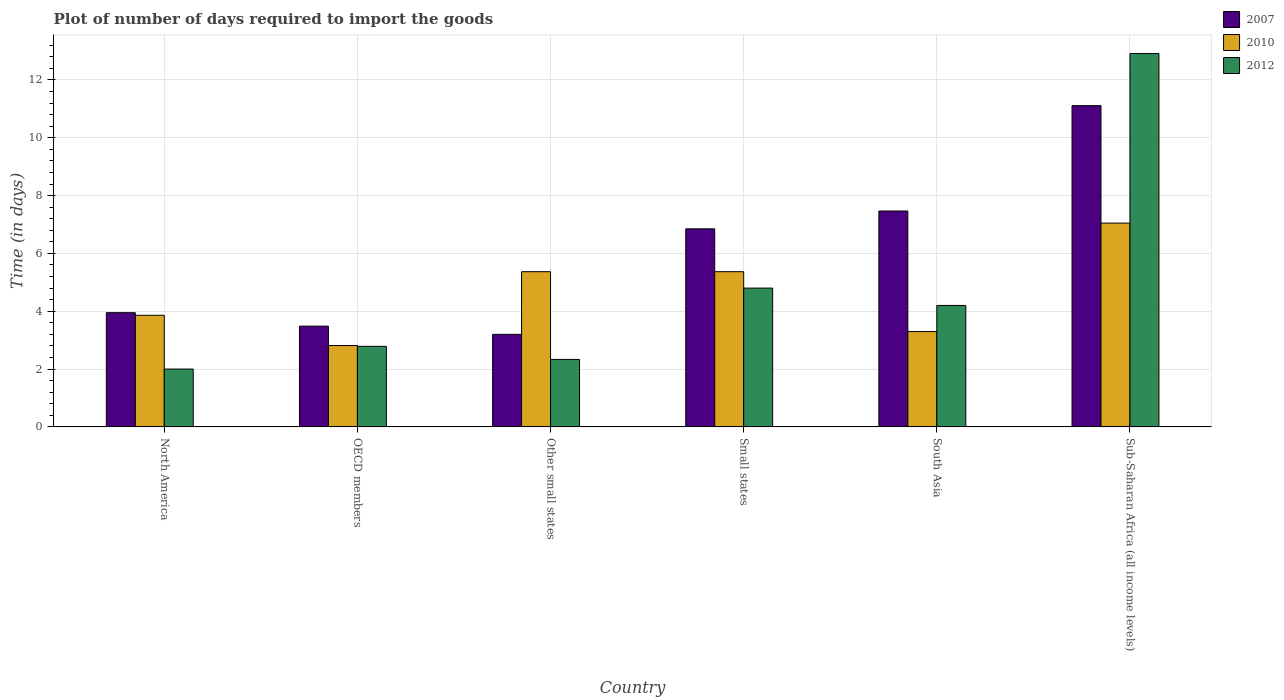How many different coloured bars are there?
Give a very brief answer. 3. How many bars are there on the 1st tick from the right?
Provide a short and direct response. 3. What is the time required to import goods in 2010 in OECD members?
Offer a very short reply. 2.81. Across all countries, what is the maximum time required to import goods in 2010?
Provide a short and direct response. 7.05. In which country was the time required to import goods in 2007 maximum?
Your response must be concise. Sub-Saharan Africa (all income levels). What is the total time required to import goods in 2012 in the graph?
Provide a short and direct response. 29.03. What is the difference between the time required to import goods in 2010 in North America and that in South Asia?
Ensure brevity in your answer.  0.56. What is the difference between the time required to import goods in 2007 in OECD members and the time required to import goods in 2012 in North America?
Provide a succinct answer. 1.48. What is the average time required to import goods in 2012 per country?
Offer a very short reply. 4.84. What is the difference between the time required to import goods of/in 2010 and time required to import goods of/in 2007 in OECD members?
Provide a succinct answer. -0.67. What is the ratio of the time required to import goods in 2007 in Other small states to that in South Asia?
Provide a succinct answer. 0.43. What is the difference between the highest and the second highest time required to import goods in 2010?
Offer a terse response. -1.68. What is the difference between the highest and the lowest time required to import goods in 2007?
Your answer should be compact. 7.91. In how many countries, is the time required to import goods in 2010 greater than the average time required to import goods in 2010 taken over all countries?
Make the answer very short. 3. Is the sum of the time required to import goods in 2010 in North America and Other small states greater than the maximum time required to import goods in 2012 across all countries?
Provide a succinct answer. No. What does the 3rd bar from the left in Sub-Saharan Africa (all income levels) represents?
Make the answer very short. 2012. Is it the case that in every country, the sum of the time required to import goods in 2010 and time required to import goods in 2007 is greater than the time required to import goods in 2012?
Offer a terse response. Yes. How many bars are there?
Make the answer very short. 18. Are all the bars in the graph horizontal?
Ensure brevity in your answer.  No. How many countries are there in the graph?
Make the answer very short. 6. What is the difference between two consecutive major ticks on the Y-axis?
Keep it short and to the point. 2. Are the values on the major ticks of Y-axis written in scientific E-notation?
Provide a short and direct response. No. Does the graph contain any zero values?
Give a very brief answer. No. Where does the legend appear in the graph?
Offer a terse response. Top right. What is the title of the graph?
Keep it short and to the point. Plot of number of days required to import the goods. Does "1964" appear as one of the legend labels in the graph?
Make the answer very short. No. What is the label or title of the X-axis?
Make the answer very short. Country. What is the label or title of the Y-axis?
Give a very brief answer. Time (in days). What is the Time (in days) of 2007 in North America?
Make the answer very short. 3.95. What is the Time (in days) of 2010 in North America?
Provide a short and direct response. 3.86. What is the Time (in days) of 2007 in OECD members?
Offer a terse response. 3.48. What is the Time (in days) of 2010 in OECD members?
Your response must be concise. 2.81. What is the Time (in days) of 2012 in OECD members?
Keep it short and to the point. 2.79. What is the Time (in days) in 2010 in Other small states?
Provide a short and direct response. 5.37. What is the Time (in days) of 2012 in Other small states?
Ensure brevity in your answer.  2.33. What is the Time (in days) of 2007 in Small states?
Your response must be concise. 6.85. What is the Time (in days) in 2010 in Small states?
Keep it short and to the point. 5.37. What is the Time (in days) of 2012 in Small states?
Give a very brief answer. 4.8. What is the Time (in days) of 2007 in South Asia?
Offer a terse response. 7.47. What is the Time (in days) in 2010 in South Asia?
Your answer should be very brief. 3.3. What is the Time (in days) in 2007 in Sub-Saharan Africa (all income levels)?
Offer a very short reply. 11.11. What is the Time (in days) in 2010 in Sub-Saharan Africa (all income levels)?
Your answer should be compact. 7.05. What is the Time (in days) of 2012 in Sub-Saharan Africa (all income levels)?
Make the answer very short. 12.91. Across all countries, what is the maximum Time (in days) in 2007?
Offer a terse response. 11.11. Across all countries, what is the maximum Time (in days) in 2010?
Provide a short and direct response. 7.05. Across all countries, what is the maximum Time (in days) of 2012?
Keep it short and to the point. 12.91. Across all countries, what is the minimum Time (in days) in 2010?
Your answer should be very brief. 2.81. What is the total Time (in days) of 2007 in the graph?
Offer a terse response. 36.06. What is the total Time (in days) in 2010 in the graph?
Provide a short and direct response. 27.75. What is the total Time (in days) of 2012 in the graph?
Your answer should be very brief. 29.03. What is the difference between the Time (in days) of 2007 in North America and that in OECD members?
Keep it short and to the point. 0.47. What is the difference between the Time (in days) in 2010 in North America and that in OECD members?
Offer a terse response. 1.05. What is the difference between the Time (in days) in 2012 in North America and that in OECD members?
Ensure brevity in your answer.  -0.79. What is the difference between the Time (in days) in 2007 in North America and that in Other small states?
Make the answer very short. 0.75. What is the difference between the Time (in days) in 2010 in North America and that in Other small states?
Give a very brief answer. -1.51. What is the difference between the Time (in days) in 2007 in North America and that in Small states?
Provide a short and direct response. -2.9. What is the difference between the Time (in days) in 2010 in North America and that in Small states?
Offer a terse response. -1.51. What is the difference between the Time (in days) of 2012 in North America and that in Small states?
Offer a very short reply. -2.8. What is the difference between the Time (in days) in 2007 in North America and that in South Asia?
Your answer should be compact. -3.52. What is the difference between the Time (in days) of 2010 in North America and that in South Asia?
Provide a succinct answer. 0.56. What is the difference between the Time (in days) of 2012 in North America and that in South Asia?
Provide a short and direct response. -2.2. What is the difference between the Time (in days) of 2007 in North America and that in Sub-Saharan Africa (all income levels)?
Offer a very short reply. -7.16. What is the difference between the Time (in days) in 2010 in North America and that in Sub-Saharan Africa (all income levels)?
Keep it short and to the point. -3.19. What is the difference between the Time (in days) of 2012 in North America and that in Sub-Saharan Africa (all income levels)?
Your answer should be compact. -10.91. What is the difference between the Time (in days) of 2007 in OECD members and that in Other small states?
Provide a short and direct response. 0.28. What is the difference between the Time (in days) in 2010 in OECD members and that in Other small states?
Give a very brief answer. -2.55. What is the difference between the Time (in days) of 2012 in OECD members and that in Other small states?
Offer a very short reply. 0.45. What is the difference between the Time (in days) of 2007 in OECD members and that in Small states?
Provide a short and direct response. -3.37. What is the difference between the Time (in days) of 2010 in OECD members and that in Small states?
Provide a succinct answer. -2.55. What is the difference between the Time (in days) of 2012 in OECD members and that in Small states?
Offer a terse response. -2.01. What is the difference between the Time (in days) in 2007 in OECD members and that in South Asia?
Your response must be concise. -3.98. What is the difference between the Time (in days) in 2010 in OECD members and that in South Asia?
Provide a succinct answer. -0.48. What is the difference between the Time (in days) of 2012 in OECD members and that in South Asia?
Make the answer very short. -1.41. What is the difference between the Time (in days) in 2007 in OECD members and that in Sub-Saharan Africa (all income levels)?
Your response must be concise. -7.63. What is the difference between the Time (in days) of 2010 in OECD members and that in Sub-Saharan Africa (all income levels)?
Give a very brief answer. -4.23. What is the difference between the Time (in days) of 2012 in OECD members and that in Sub-Saharan Africa (all income levels)?
Provide a succinct answer. -10.13. What is the difference between the Time (in days) in 2007 in Other small states and that in Small states?
Provide a succinct answer. -3.65. What is the difference between the Time (in days) in 2010 in Other small states and that in Small states?
Provide a short and direct response. 0. What is the difference between the Time (in days) in 2012 in Other small states and that in Small states?
Give a very brief answer. -2.47. What is the difference between the Time (in days) of 2007 in Other small states and that in South Asia?
Provide a short and direct response. -4.27. What is the difference between the Time (in days) of 2010 in Other small states and that in South Asia?
Make the answer very short. 2.07. What is the difference between the Time (in days) of 2012 in Other small states and that in South Asia?
Provide a short and direct response. -1.87. What is the difference between the Time (in days) of 2007 in Other small states and that in Sub-Saharan Africa (all income levels)?
Make the answer very short. -7.91. What is the difference between the Time (in days) in 2010 in Other small states and that in Sub-Saharan Africa (all income levels)?
Provide a short and direct response. -1.68. What is the difference between the Time (in days) in 2012 in Other small states and that in Sub-Saharan Africa (all income levels)?
Make the answer very short. -10.58. What is the difference between the Time (in days) of 2007 in Small states and that in South Asia?
Your response must be concise. -0.62. What is the difference between the Time (in days) of 2010 in Small states and that in South Asia?
Offer a terse response. 2.07. What is the difference between the Time (in days) in 2012 in Small states and that in South Asia?
Give a very brief answer. 0.6. What is the difference between the Time (in days) of 2007 in Small states and that in Sub-Saharan Africa (all income levels)?
Provide a succinct answer. -4.26. What is the difference between the Time (in days) in 2010 in Small states and that in Sub-Saharan Africa (all income levels)?
Give a very brief answer. -1.68. What is the difference between the Time (in days) in 2012 in Small states and that in Sub-Saharan Africa (all income levels)?
Ensure brevity in your answer.  -8.11. What is the difference between the Time (in days) in 2007 in South Asia and that in Sub-Saharan Africa (all income levels)?
Make the answer very short. -3.64. What is the difference between the Time (in days) of 2010 in South Asia and that in Sub-Saharan Africa (all income levels)?
Your answer should be very brief. -3.75. What is the difference between the Time (in days) of 2012 in South Asia and that in Sub-Saharan Africa (all income levels)?
Offer a very short reply. -8.71. What is the difference between the Time (in days) in 2007 in North America and the Time (in days) in 2010 in OECD members?
Provide a succinct answer. 1.14. What is the difference between the Time (in days) in 2007 in North America and the Time (in days) in 2012 in OECD members?
Your answer should be very brief. 1.16. What is the difference between the Time (in days) of 2010 in North America and the Time (in days) of 2012 in OECD members?
Provide a short and direct response. 1.07. What is the difference between the Time (in days) in 2007 in North America and the Time (in days) in 2010 in Other small states?
Your answer should be compact. -1.42. What is the difference between the Time (in days) in 2007 in North America and the Time (in days) in 2012 in Other small states?
Make the answer very short. 1.62. What is the difference between the Time (in days) in 2010 in North America and the Time (in days) in 2012 in Other small states?
Offer a very short reply. 1.53. What is the difference between the Time (in days) of 2007 in North America and the Time (in days) of 2010 in Small states?
Make the answer very short. -1.42. What is the difference between the Time (in days) of 2007 in North America and the Time (in days) of 2012 in Small states?
Provide a succinct answer. -0.85. What is the difference between the Time (in days) of 2010 in North America and the Time (in days) of 2012 in Small states?
Offer a terse response. -0.94. What is the difference between the Time (in days) of 2007 in North America and the Time (in days) of 2010 in South Asia?
Keep it short and to the point. 0.65. What is the difference between the Time (in days) of 2010 in North America and the Time (in days) of 2012 in South Asia?
Offer a terse response. -0.34. What is the difference between the Time (in days) in 2007 in North America and the Time (in days) in 2010 in Sub-Saharan Africa (all income levels)?
Provide a succinct answer. -3.1. What is the difference between the Time (in days) of 2007 in North America and the Time (in days) of 2012 in Sub-Saharan Africa (all income levels)?
Provide a short and direct response. -8.96. What is the difference between the Time (in days) in 2010 in North America and the Time (in days) in 2012 in Sub-Saharan Africa (all income levels)?
Your answer should be compact. -9.05. What is the difference between the Time (in days) in 2007 in OECD members and the Time (in days) in 2010 in Other small states?
Your answer should be compact. -1.88. What is the difference between the Time (in days) in 2007 in OECD members and the Time (in days) in 2012 in Other small states?
Make the answer very short. 1.15. What is the difference between the Time (in days) of 2010 in OECD members and the Time (in days) of 2012 in Other small states?
Provide a succinct answer. 0.48. What is the difference between the Time (in days) of 2007 in OECD members and the Time (in days) of 2010 in Small states?
Provide a short and direct response. -1.88. What is the difference between the Time (in days) in 2007 in OECD members and the Time (in days) in 2012 in Small states?
Ensure brevity in your answer.  -1.32. What is the difference between the Time (in days) in 2010 in OECD members and the Time (in days) in 2012 in Small states?
Offer a very short reply. -1.99. What is the difference between the Time (in days) in 2007 in OECD members and the Time (in days) in 2010 in South Asia?
Give a very brief answer. 0.19. What is the difference between the Time (in days) of 2007 in OECD members and the Time (in days) of 2012 in South Asia?
Make the answer very short. -0.72. What is the difference between the Time (in days) of 2010 in OECD members and the Time (in days) of 2012 in South Asia?
Make the answer very short. -1.39. What is the difference between the Time (in days) of 2007 in OECD members and the Time (in days) of 2010 in Sub-Saharan Africa (all income levels)?
Give a very brief answer. -3.56. What is the difference between the Time (in days) in 2007 in OECD members and the Time (in days) in 2012 in Sub-Saharan Africa (all income levels)?
Keep it short and to the point. -9.43. What is the difference between the Time (in days) in 2010 in OECD members and the Time (in days) in 2012 in Sub-Saharan Africa (all income levels)?
Provide a succinct answer. -10.1. What is the difference between the Time (in days) of 2007 in Other small states and the Time (in days) of 2010 in Small states?
Provide a short and direct response. -2.17. What is the difference between the Time (in days) of 2010 in Other small states and the Time (in days) of 2012 in Small states?
Offer a terse response. 0.57. What is the difference between the Time (in days) in 2007 in Other small states and the Time (in days) in 2010 in South Asia?
Your answer should be compact. -0.1. What is the difference between the Time (in days) of 2010 in Other small states and the Time (in days) of 2012 in South Asia?
Make the answer very short. 1.17. What is the difference between the Time (in days) of 2007 in Other small states and the Time (in days) of 2010 in Sub-Saharan Africa (all income levels)?
Give a very brief answer. -3.85. What is the difference between the Time (in days) of 2007 in Other small states and the Time (in days) of 2012 in Sub-Saharan Africa (all income levels)?
Provide a succinct answer. -9.71. What is the difference between the Time (in days) of 2010 in Other small states and the Time (in days) of 2012 in Sub-Saharan Africa (all income levels)?
Give a very brief answer. -7.55. What is the difference between the Time (in days) in 2007 in Small states and the Time (in days) in 2010 in South Asia?
Provide a succinct answer. 3.55. What is the difference between the Time (in days) of 2007 in Small states and the Time (in days) of 2012 in South Asia?
Provide a short and direct response. 2.65. What is the difference between the Time (in days) of 2010 in Small states and the Time (in days) of 2012 in South Asia?
Make the answer very short. 1.17. What is the difference between the Time (in days) of 2007 in Small states and the Time (in days) of 2010 in Sub-Saharan Africa (all income levels)?
Make the answer very short. -0.2. What is the difference between the Time (in days) of 2007 in Small states and the Time (in days) of 2012 in Sub-Saharan Africa (all income levels)?
Give a very brief answer. -6.06. What is the difference between the Time (in days) of 2010 in Small states and the Time (in days) of 2012 in Sub-Saharan Africa (all income levels)?
Provide a short and direct response. -7.55. What is the difference between the Time (in days) in 2007 in South Asia and the Time (in days) in 2010 in Sub-Saharan Africa (all income levels)?
Provide a short and direct response. 0.42. What is the difference between the Time (in days) in 2007 in South Asia and the Time (in days) in 2012 in Sub-Saharan Africa (all income levels)?
Your answer should be very brief. -5.45. What is the difference between the Time (in days) in 2010 in South Asia and the Time (in days) in 2012 in Sub-Saharan Africa (all income levels)?
Provide a short and direct response. -9.62. What is the average Time (in days) in 2007 per country?
Ensure brevity in your answer.  6.01. What is the average Time (in days) of 2010 per country?
Give a very brief answer. 4.63. What is the average Time (in days) in 2012 per country?
Offer a terse response. 4.84. What is the difference between the Time (in days) of 2007 and Time (in days) of 2010 in North America?
Provide a short and direct response. 0.09. What is the difference between the Time (in days) of 2007 and Time (in days) of 2012 in North America?
Ensure brevity in your answer.  1.95. What is the difference between the Time (in days) of 2010 and Time (in days) of 2012 in North America?
Give a very brief answer. 1.86. What is the difference between the Time (in days) in 2007 and Time (in days) in 2010 in OECD members?
Your answer should be very brief. 0.67. What is the difference between the Time (in days) of 2007 and Time (in days) of 2012 in OECD members?
Provide a short and direct response. 0.7. What is the difference between the Time (in days) of 2010 and Time (in days) of 2012 in OECD members?
Offer a very short reply. 0.03. What is the difference between the Time (in days) of 2007 and Time (in days) of 2010 in Other small states?
Make the answer very short. -2.17. What is the difference between the Time (in days) in 2007 and Time (in days) in 2012 in Other small states?
Keep it short and to the point. 0.87. What is the difference between the Time (in days) in 2010 and Time (in days) in 2012 in Other small states?
Make the answer very short. 3.03. What is the difference between the Time (in days) of 2007 and Time (in days) of 2010 in Small states?
Keep it short and to the point. 1.48. What is the difference between the Time (in days) of 2007 and Time (in days) of 2012 in Small states?
Make the answer very short. 2.05. What is the difference between the Time (in days) in 2010 and Time (in days) in 2012 in Small states?
Your answer should be compact. 0.57. What is the difference between the Time (in days) of 2007 and Time (in days) of 2010 in South Asia?
Your answer should be very brief. 4.17. What is the difference between the Time (in days) in 2007 and Time (in days) in 2012 in South Asia?
Your response must be concise. 3.27. What is the difference between the Time (in days) in 2010 and Time (in days) in 2012 in South Asia?
Provide a short and direct response. -0.9. What is the difference between the Time (in days) in 2007 and Time (in days) in 2010 in Sub-Saharan Africa (all income levels)?
Provide a succinct answer. 4.06. What is the difference between the Time (in days) of 2007 and Time (in days) of 2012 in Sub-Saharan Africa (all income levels)?
Offer a very short reply. -1.8. What is the difference between the Time (in days) in 2010 and Time (in days) in 2012 in Sub-Saharan Africa (all income levels)?
Your answer should be very brief. -5.86. What is the ratio of the Time (in days) of 2007 in North America to that in OECD members?
Give a very brief answer. 1.13. What is the ratio of the Time (in days) in 2010 in North America to that in OECD members?
Ensure brevity in your answer.  1.37. What is the ratio of the Time (in days) of 2012 in North America to that in OECD members?
Offer a very short reply. 0.72. What is the ratio of the Time (in days) of 2007 in North America to that in Other small states?
Offer a very short reply. 1.23. What is the ratio of the Time (in days) of 2010 in North America to that in Other small states?
Keep it short and to the point. 0.72. What is the ratio of the Time (in days) of 2012 in North America to that in Other small states?
Offer a very short reply. 0.86. What is the ratio of the Time (in days) in 2007 in North America to that in Small states?
Give a very brief answer. 0.58. What is the ratio of the Time (in days) of 2010 in North America to that in Small states?
Ensure brevity in your answer.  0.72. What is the ratio of the Time (in days) in 2012 in North America to that in Small states?
Your response must be concise. 0.42. What is the ratio of the Time (in days) in 2007 in North America to that in South Asia?
Give a very brief answer. 0.53. What is the ratio of the Time (in days) in 2010 in North America to that in South Asia?
Make the answer very short. 1.17. What is the ratio of the Time (in days) of 2012 in North America to that in South Asia?
Provide a succinct answer. 0.48. What is the ratio of the Time (in days) in 2007 in North America to that in Sub-Saharan Africa (all income levels)?
Give a very brief answer. 0.36. What is the ratio of the Time (in days) of 2010 in North America to that in Sub-Saharan Africa (all income levels)?
Your answer should be compact. 0.55. What is the ratio of the Time (in days) in 2012 in North America to that in Sub-Saharan Africa (all income levels)?
Make the answer very short. 0.15. What is the ratio of the Time (in days) of 2007 in OECD members to that in Other small states?
Provide a succinct answer. 1.09. What is the ratio of the Time (in days) in 2010 in OECD members to that in Other small states?
Provide a short and direct response. 0.52. What is the ratio of the Time (in days) in 2012 in OECD members to that in Other small states?
Make the answer very short. 1.19. What is the ratio of the Time (in days) in 2007 in OECD members to that in Small states?
Provide a succinct answer. 0.51. What is the ratio of the Time (in days) in 2010 in OECD members to that in Small states?
Make the answer very short. 0.52. What is the ratio of the Time (in days) of 2012 in OECD members to that in Small states?
Give a very brief answer. 0.58. What is the ratio of the Time (in days) in 2007 in OECD members to that in South Asia?
Provide a short and direct response. 0.47. What is the ratio of the Time (in days) in 2010 in OECD members to that in South Asia?
Provide a succinct answer. 0.85. What is the ratio of the Time (in days) of 2012 in OECD members to that in South Asia?
Offer a terse response. 0.66. What is the ratio of the Time (in days) of 2007 in OECD members to that in Sub-Saharan Africa (all income levels)?
Give a very brief answer. 0.31. What is the ratio of the Time (in days) of 2010 in OECD members to that in Sub-Saharan Africa (all income levels)?
Offer a terse response. 0.4. What is the ratio of the Time (in days) in 2012 in OECD members to that in Sub-Saharan Africa (all income levels)?
Ensure brevity in your answer.  0.22. What is the ratio of the Time (in days) in 2007 in Other small states to that in Small states?
Ensure brevity in your answer.  0.47. What is the ratio of the Time (in days) of 2012 in Other small states to that in Small states?
Provide a succinct answer. 0.49. What is the ratio of the Time (in days) in 2007 in Other small states to that in South Asia?
Your response must be concise. 0.43. What is the ratio of the Time (in days) of 2010 in Other small states to that in South Asia?
Your answer should be compact. 1.63. What is the ratio of the Time (in days) in 2012 in Other small states to that in South Asia?
Make the answer very short. 0.56. What is the ratio of the Time (in days) of 2007 in Other small states to that in Sub-Saharan Africa (all income levels)?
Provide a succinct answer. 0.29. What is the ratio of the Time (in days) of 2010 in Other small states to that in Sub-Saharan Africa (all income levels)?
Your answer should be compact. 0.76. What is the ratio of the Time (in days) in 2012 in Other small states to that in Sub-Saharan Africa (all income levels)?
Your answer should be very brief. 0.18. What is the ratio of the Time (in days) in 2007 in Small states to that in South Asia?
Give a very brief answer. 0.92. What is the ratio of the Time (in days) of 2010 in Small states to that in South Asia?
Ensure brevity in your answer.  1.63. What is the ratio of the Time (in days) in 2007 in Small states to that in Sub-Saharan Africa (all income levels)?
Your response must be concise. 0.62. What is the ratio of the Time (in days) of 2010 in Small states to that in Sub-Saharan Africa (all income levels)?
Offer a very short reply. 0.76. What is the ratio of the Time (in days) in 2012 in Small states to that in Sub-Saharan Africa (all income levels)?
Your answer should be very brief. 0.37. What is the ratio of the Time (in days) of 2007 in South Asia to that in Sub-Saharan Africa (all income levels)?
Provide a succinct answer. 0.67. What is the ratio of the Time (in days) of 2010 in South Asia to that in Sub-Saharan Africa (all income levels)?
Ensure brevity in your answer.  0.47. What is the ratio of the Time (in days) in 2012 in South Asia to that in Sub-Saharan Africa (all income levels)?
Your answer should be compact. 0.33. What is the difference between the highest and the second highest Time (in days) in 2007?
Your answer should be compact. 3.64. What is the difference between the highest and the second highest Time (in days) in 2010?
Offer a very short reply. 1.68. What is the difference between the highest and the second highest Time (in days) in 2012?
Your response must be concise. 8.11. What is the difference between the highest and the lowest Time (in days) of 2007?
Provide a short and direct response. 7.91. What is the difference between the highest and the lowest Time (in days) of 2010?
Offer a very short reply. 4.23. What is the difference between the highest and the lowest Time (in days) of 2012?
Give a very brief answer. 10.91. 